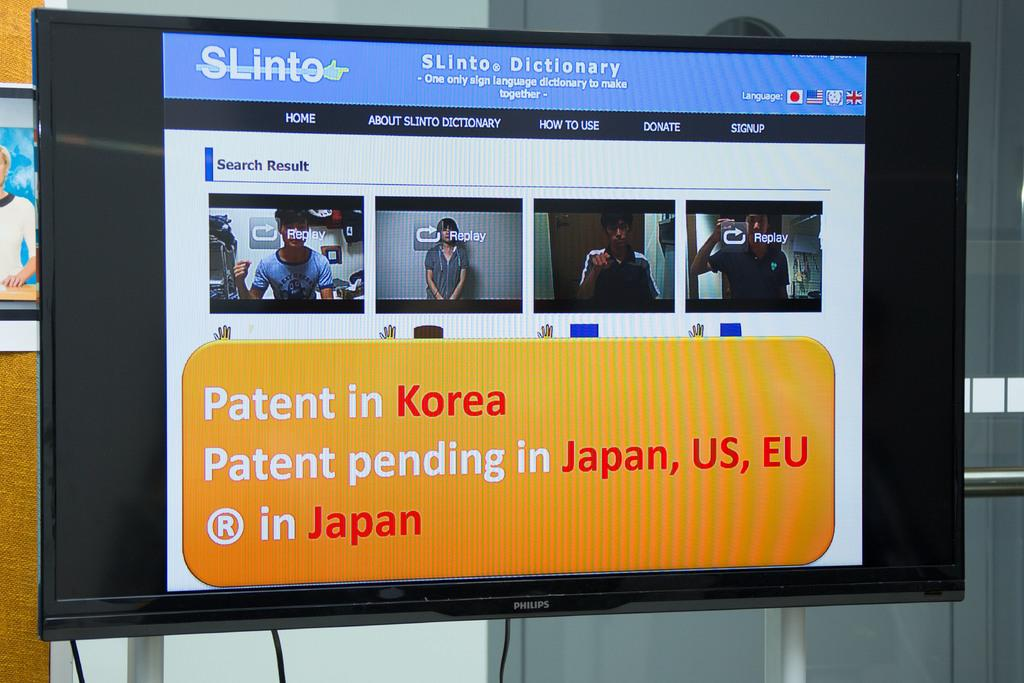<image>
Describe the image concisely. a tv that is on that says 'patent in korea' on the screen 